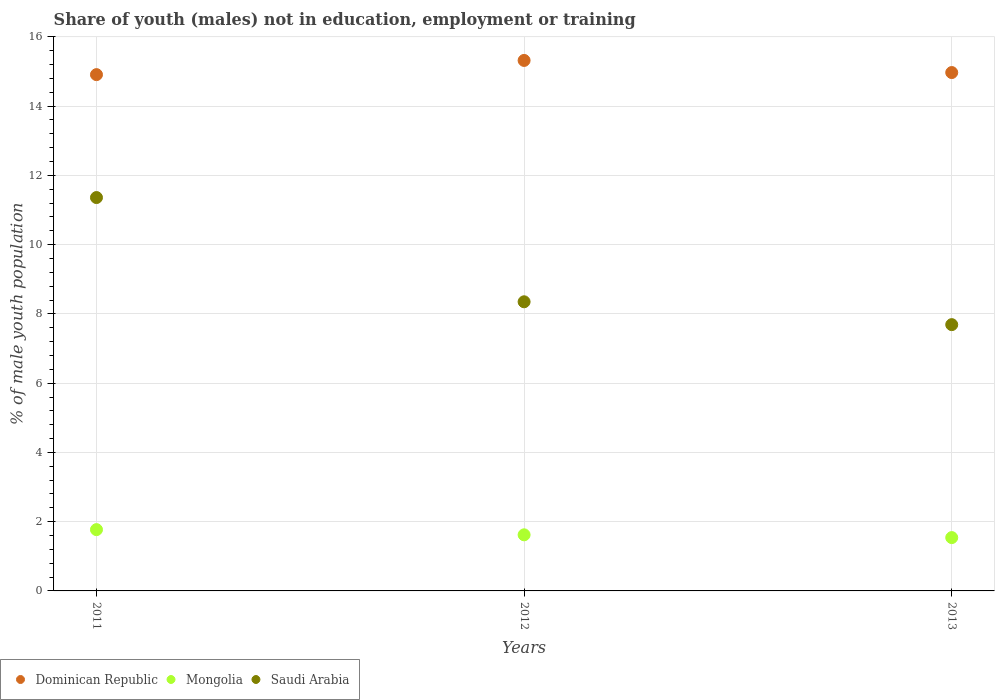Is the number of dotlines equal to the number of legend labels?
Provide a short and direct response. Yes. What is the percentage of unemployed males population in in Saudi Arabia in 2011?
Ensure brevity in your answer.  11.36. Across all years, what is the maximum percentage of unemployed males population in in Mongolia?
Provide a succinct answer. 1.77. Across all years, what is the minimum percentage of unemployed males population in in Saudi Arabia?
Ensure brevity in your answer.  7.69. In which year was the percentage of unemployed males population in in Saudi Arabia minimum?
Your answer should be very brief. 2013. What is the total percentage of unemployed males population in in Dominican Republic in the graph?
Offer a terse response. 45.2. What is the difference between the percentage of unemployed males population in in Dominican Republic in 2012 and that in 2013?
Your answer should be very brief. 0.35. What is the difference between the percentage of unemployed males population in in Mongolia in 2011 and the percentage of unemployed males population in in Dominican Republic in 2013?
Offer a terse response. -13.2. What is the average percentage of unemployed males population in in Dominican Republic per year?
Ensure brevity in your answer.  15.07. In the year 2012, what is the difference between the percentage of unemployed males population in in Saudi Arabia and percentage of unemployed males population in in Mongolia?
Give a very brief answer. 6.73. What is the ratio of the percentage of unemployed males population in in Dominican Republic in 2011 to that in 2012?
Give a very brief answer. 0.97. Is the percentage of unemployed males population in in Saudi Arabia in 2011 less than that in 2013?
Offer a very short reply. No. Is the difference between the percentage of unemployed males population in in Saudi Arabia in 2011 and 2013 greater than the difference between the percentage of unemployed males population in in Mongolia in 2011 and 2013?
Offer a terse response. Yes. What is the difference between the highest and the second highest percentage of unemployed males population in in Saudi Arabia?
Give a very brief answer. 3.01. What is the difference between the highest and the lowest percentage of unemployed males population in in Mongolia?
Your response must be concise. 0.23. In how many years, is the percentage of unemployed males population in in Mongolia greater than the average percentage of unemployed males population in in Mongolia taken over all years?
Your response must be concise. 1. Is it the case that in every year, the sum of the percentage of unemployed males population in in Saudi Arabia and percentage of unemployed males population in in Dominican Republic  is greater than the percentage of unemployed males population in in Mongolia?
Your answer should be very brief. Yes. Is the percentage of unemployed males population in in Mongolia strictly greater than the percentage of unemployed males population in in Dominican Republic over the years?
Your answer should be compact. No. Where does the legend appear in the graph?
Provide a short and direct response. Bottom left. How many legend labels are there?
Give a very brief answer. 3. What is the title of the graph?
Offer a very short reply. Share of youth (males) not in education, employment or training. What is the label or title of the X-axis?
Your response must be concise. Years. What is the label or title of the Y-axis?
Give a very brief answer. % of male youth population. What is the % of male youth population of Dominican Republic in 2011?
Provide a succinct answer. 14.91. What is the % of male youth population of Mongolia in 2011?
Keep it short and to the point. 1.77. What is the % of male youth population in Saudi Arabia in 2011?
Ensure brevity in your answer.  11.36. What is the % of male youth population of Dominican Republic in 2012?
Keep it short and to the point. 15.32. What is the % of male youth population in Mongolia in 2012?
Ensure brevity in your answer.  1.62. What is the % of male youth population of Saudi Arabia in 2012?
Your answer should be very brief. 8.35. What is the % of male youth population of Dominican Republic in 2013?
Provide a short and direct response. 14.97. What is the % of male youth population of Mongolia in 2013?
Offer a terse response. 1.54. What is the % of male youth population in Saudi Arabia in 2013?
Give a very brief answer. 7.69. Across all years, what is the maximum % of male youth population in Dominican Republic?
Your answer should be compact. 15.32. Across all years, what is the maximum % of male youth population in Mongolia?
Your answer should be compact. 1.77. Across all years, what is the maximum % of male youth population of Saudi Arabia?
Provide a succinct answer. 11.36. Across all years, what is the minimum % of male youth population of Dominican Republic?
Your response must be concise. 14.91. Across all years, what is the minimum % of male youth population in Mongolia?
Offer a terse response. 1.54. Across all years, what is the minimum % of male youth population of Saudi Arabia?
Your response must be concise. 7.69. What is the total % of male youth population in Dominican Republic in the graph?
Your answer should be compact. 45.2. What is the total % of male youth population of Mongolia in the graph?
Your answer should be very brief. 4.93. What is the total % of male youth population of Saudi Arabia in the graph?
Provide a succinct answer. 27.4. What is the difference between the % of male youth population in Dominican Republic in 2011 and that in 2012?
Your answer should be compact. -0.41. What is the difference between the % of male youth population of Mongolia in 2011 and that in 2012?
Your response must be concise. 0.15. What is the difference between the % of male youth population in Saudi Arabia in 2011 and that in 2012?
Provide a short and direct response. 3.01. What is the difference between the % of male youth population of Dominican Republic in 2011 and that in 2013?
Give a very brief answer. -0.06. What is the difference between the % of male youth population of Mongolia in 2011 and that in 2013?
Give a very brief answer. 0.23. What is the difference between the % of male youth population in Saudi Arabia in 2011 and that in 2013?
Make the answer very short. 3.67. What is the difference between the % of male youth population of Dominican Republic in 2012 and that in 2013?
Give a very brief answer. 0.35. What is the difference between the % of male youth population of Mongolia in 2012 and that in 2013?
Provide a succinct answer. 0.08. What is the difference between the % of male youth population of Saudi Arabia in 2012 and that in 2013?
Make the answer very short. 0.66. What is the difference between the % of male youth population of Dominican Republic in 2011 and the % of male youth population of Mongolia in 2012?
Your answer should be compact. 13.29. What is the difference between the % of male youth population in Dominican Republic in 2011 and the % of male youth population in Saudi Arabia in 2012?
Ensure brevity in your answer.  6.56. What is the difference between the % of male youth population in Mongolia in 2011 and the % of male youth population in Saudi Arabia in 2012?
Offer a very short reply. -6.58. What is the difference between the % of male youth population in Dominican Republic in 2011 and the % of male youth population in Mongolia in 2013?
Make the answer very short. 13.37. What is the difference between the % of male youth population in Dominican Republic in 2011 and the % of male youth population in Saudi Arabia in 2013?
Give a very brief answer. 7.22. What is the difference between the % of male youth population of Mongolia in 2011 and the % of male youth population of Saudi Arabia in 2013?
Provide a short and direct response. -5.92. What is the difference between the % of male youth population of Dominican Republic in 2012 and the % of male youth population of Mongolia in 2013?
Offer a terse response. 13.78. What is the difference between the % of male youth population of Dominican Republic in 2012 and the % of male youth population of Saudi Arabia in 2013?
Ensure brevity in your answer.  7.63. What is the difference between the % of male youth population of Mongolia in 2012 and the % of male youth population of Saudi Arabia in 2013?
Keep it short and to the point. -6.07. What is the average % of male youth population in Dominican Republic per year?
Make the answer very short. 15.07. What is the average % of male youth population in Mongolia per year?
Your answer should be very brief. 1.64. What is the average % of male youth population in Saudi Arabia per year?
Your answer should be compact. 9.13. In the year 2011, what is the difference between the % of male youth population in Dominican Republic and % of male youth population in Mongolia?
Offer a very short reply. 13.14. In the year 2011, what is the difference between the % of male youth population in Dominican Republic and % of male youth population in Saudi Arabia?
Your answer should be compact. 3.55. In the year 2011, what is the difference between the % of male youth population of Mongolia and % of male youth population of Saudi Arabia?
Keep it short and to the point. -9.59. In the year 2012, what is the difference between the % of male youth population in Dominican Republic and % of male youth population in Saudi Arabia?
Provide a succinct answer. 6.97. In the year 2012, what is the difference between the % of male youth population in Mongolia and % of male youth population in Saudi Arabia?
Your response must be concise. -6.73. In the year 2013, what is the difference between the % of male youth population in Dominican Republic and % of male youth population in Mongolia?
Your response must be concise. 13.43. In the year 2013, what is the difference between the % of male youth population in Dominican Republic and % of male youth population in Saudi Arabia?
Ensure brevity in your answer.  7.28. In the year 2013, what is the difference between the % of male youth population of Mongolia and % of male youth population of Saudi Arabia?
Ensure brevity in your answer.  -6.15. What is the ratio of the % of male youth population of Dominican Republic in 2011 to that in 2012?
Provide a short and direct response. 0.97. What is the ratio of the % of male youth population in Mongolia in 2011 to that in 2012?
Your answer should be very brief. 1.09. What is the ratio of the % of male youth population of Saudi Arabia in 2011 to that in 2012?
Your answer should be compact. 1.36. What is the ratio of the % of male youth population in Dominican Republic in 2011 to that in 2013?
Your response must be concise. 1. What is the ratio of the % of male youth population in Mongolia in 2011 to that in 2013?
Your answer should be very brief. 1.15. What is the ratio of the % of male youth population of Saudi Arabia in 2011 to that in 2013?
Offer a terse response. 1.48. What is the ratio of the % of male youth population in Dominican Republic in 2012 to that in 2013?
Provide a succinct answer. 1.02. What is the ratio of the % of male youth population of Mongolia in 2012 to that in 2013?
Offer a very short reply. 1.05. What is the ratio of the % of male youth population of Saudi Arabia in 2012 to that in 2013?
Your answer should be compact. 1.09. What is the difference between the highest and the second highest % of male youth population of Dominican Republic?
Offer a terse response. 0.35. What is the difference between the highest and the second highest % of male youth population in Mongolia?
Offer a very short reply. 0.15. What is the difference between the highest and the second highest % of male youth population in Saudi Arabia?
Your answer should be compact. 3.01. What is the difference between the highest and the lowest % of male youth population of Dominican Republic?
Ensure brevity in your answer.  0.41. What is the difference between the highest and the lowest % of male youth population of Mongolia?
Offer a very short reply. 0.23. What is the difference between the highest and the lowest % of male youth population of Saudi Arabia?
Make the answer very short. 3.67. 